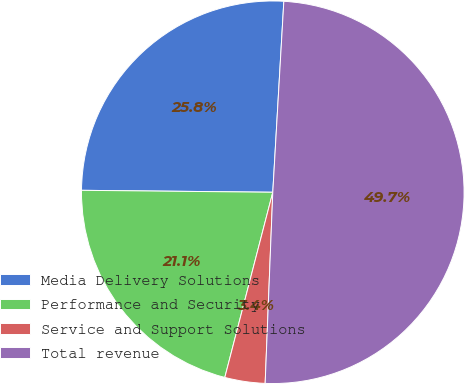Convert chart. <chart><loc_0><loc_0><loc_500><loc_500><pie_chart><fcel>Media Delivery Solutions<fcel>Performance and Security<fcel>Service and Support Solutions<fcel>Total revenue<nl><fcel>25.76%<fcel>21.13%<fcel>3.4%<fcel>49.72%<nl></chart> 